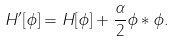Convert formula to latex. <formula><loc_0><loc_0><loc_500><loc_500>H ^ { \prime } [ \phi ] = H [ \phi ] + \frac { \alpha } { 2 } \phi * \phi .</formula> 